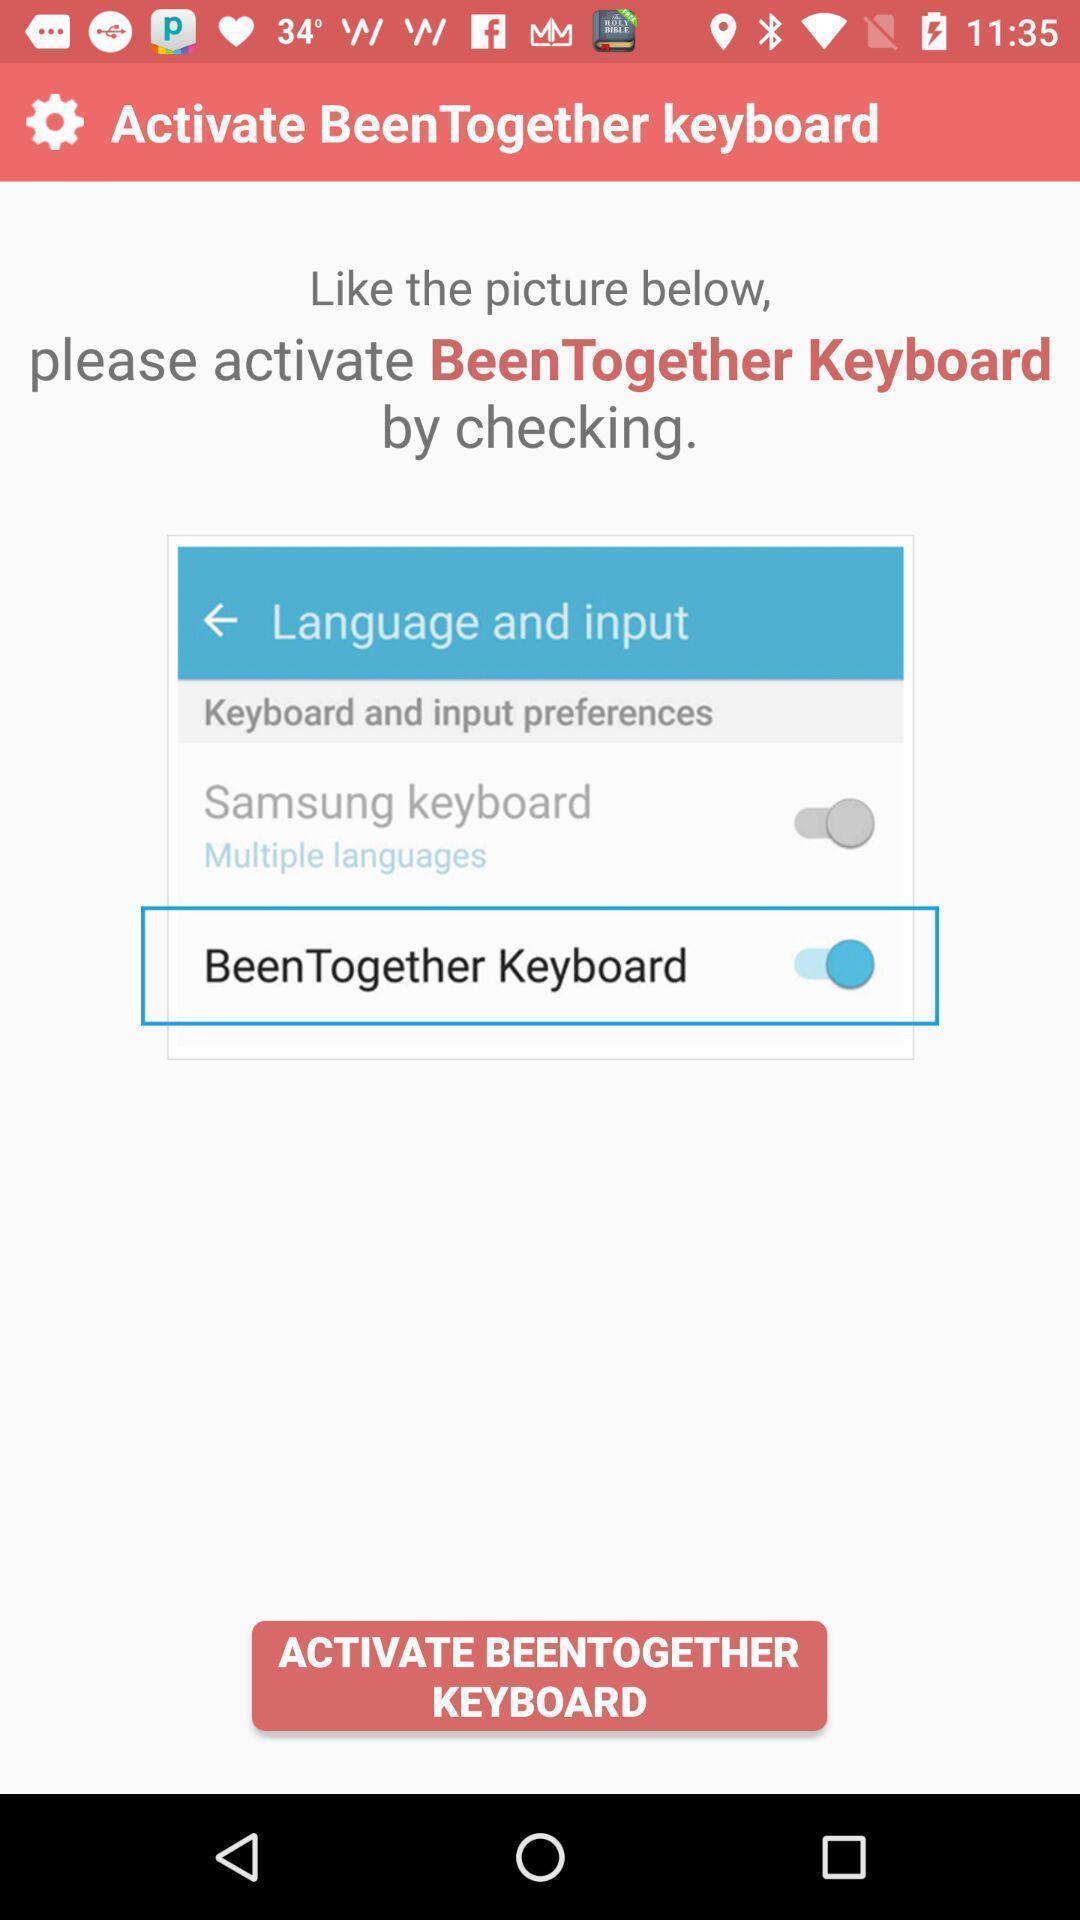Explain the elements present in this screenshot. Settings page to activate a keyboard. 